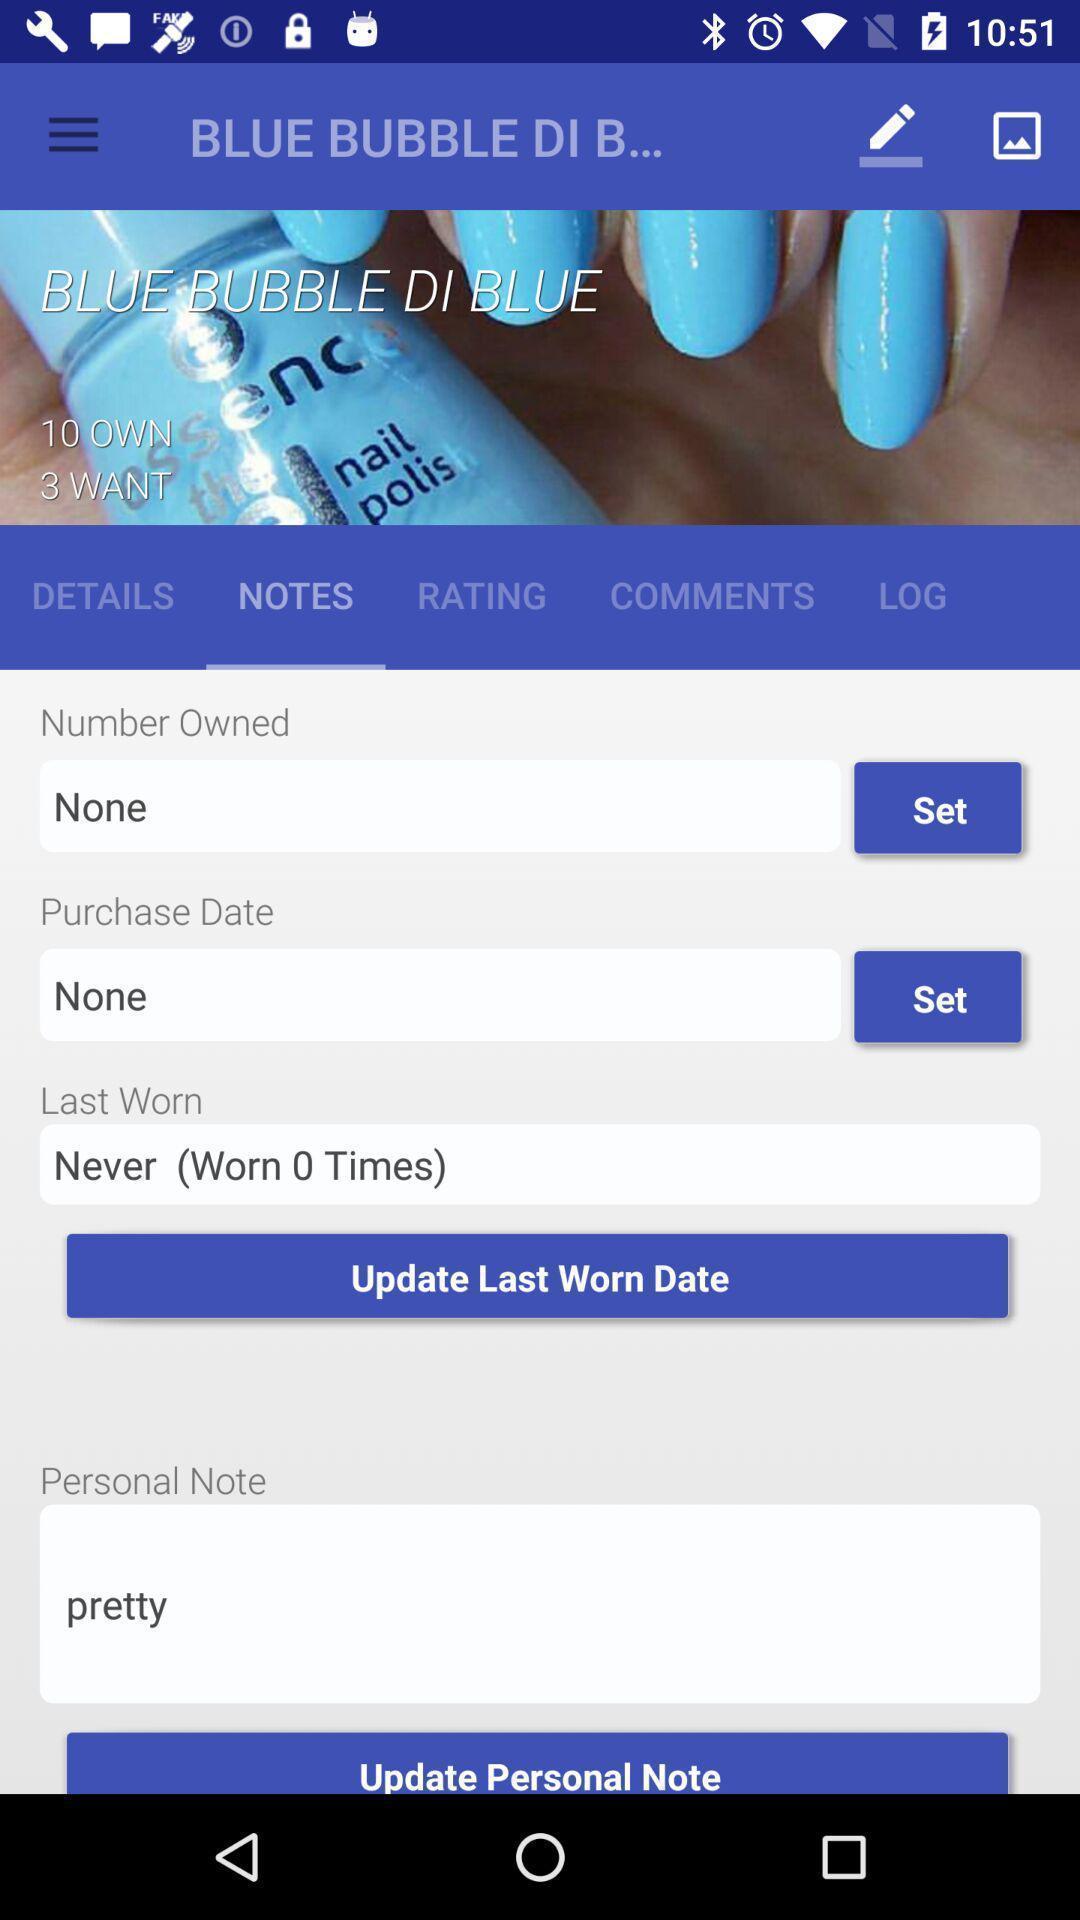Describe the visual elements of this screenshot. Screen displaying the notes page. 